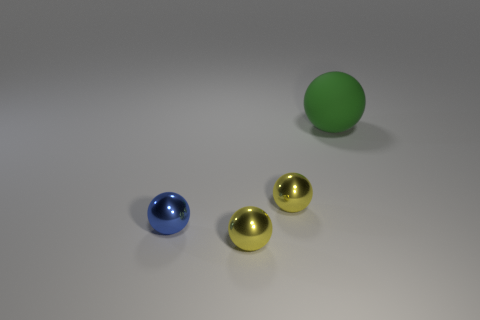Are there any other things that are made of the same material as the large ball?
Offer a very short reply. No. Is there anything else that has the same size as the green ball?
Provide a succinct answer. No. Is the number of blue things to the left of the big green rubber ball less than the number of small balls to the right of the small blue metal sphere?
Provide a short and direct response. Yes. There is a tiny metal object that is in front of the blue metallic object; what is its color?
Your answer should be very brief. Yellow. There is a metal object on the right side of the thing in front of the tiny blue shiny thing; what number of large objects are behind it?
Make the answer very short. 1. The blue sphere has what size?
Offer a very short reply. Small. There is a matte object; how many yellow objects are to the left of it?
Give a very brief answer. 2. Is the material of the yellow ball in front of the blue object the same as the big green sphere that is behind the blue shiny thing?
Provide a succinct answer. No. What shape is the small yellow thing that is in front of the metallic sphere that is on the right side of the sphere in front of the tiny blue metallic thing?
Offer a very short reply. Sphere. The big green object has what shape?
Your answer should be compact. Sphere. 